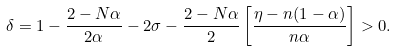Convert formula to latex. <formula><loc_0><loc_0><loc_500><loc_500>\delta = 1 - \frac { 2 - N \alpha } { 2 \alpha } - 2 \sigma - \frac { 2 - N \alpha } { 2 } \left [ \frac { \eta - n ( 1 - \alpha ) } { n \alpha } \right ] > 0 .</formula> 